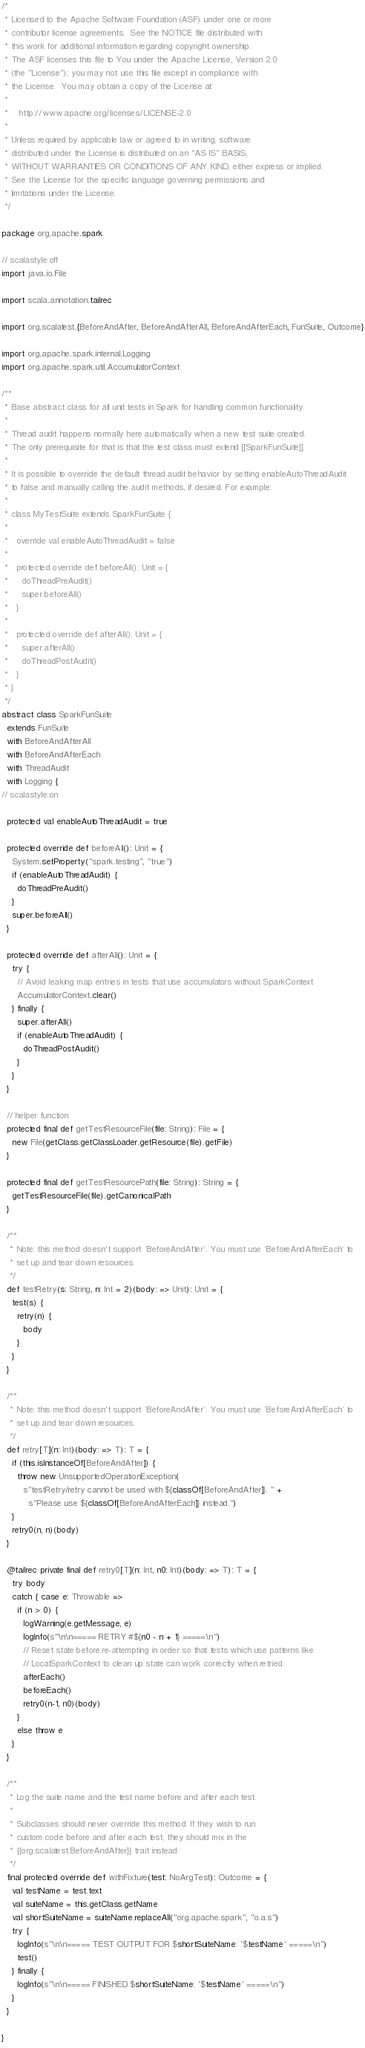Convert code to text. <code><loc_0><loc_0><loc_500><loc_500><_Scala_>/*
 * Licensed to the Apache Software Foundation (ASF) under one or more
 * contributor license agreements.  See the NOTICE file distributed with
 * this work for additional information regarding copyright ownership.
 * The ASF licenses this file to You under the Apache License, Version 2.0
 * (the "License"); you may not use this file except in compliance with
 * the License.  You may obtain a copy of the License at
 *
 *    http://www.apache.org/licenses/LICENSE-2.0
 *
 * Unless required by applicable law or agreed to in writing, software
 * distributed under the License is distributed on an "AS IS" BASIS,
 * WITHOUT WARRANTIES OR CONDITIONS OF ANY KIND, either express or implied.
 * See the License for the specific language governing permissions and
 * limitations under the License.
 */

package org.apache.spark

// scalastyle:off
import java.io.File

import scala.annotation.tailrec

import org.scalatest.{BeforeAndAfter, BeforeAndAfterAll, BeforeAndAfterEach, FunSuite, Outcome}

import org.apache.spark.internal.Logging
import org.apache.spark.util.AccumulatorContext

/**
 * Base abstract class for all unit tests in Spark for handling common functionality.
 *
 * Thread audit happens normally here automatically when a new test suite created.
 * The only prerequisite for that is that the test class must extend [[SparkFunSuite]].
 *
 * It is possible to override the default thread audit behavior by setting enableAutoThreadAudit
 * to false and manually calling the audit methods, if desired. For example:
 *
 * class MyTestSuite extends SparkFunSuite {
 *
 *   override val enableAutoThreadAudit = false
 *
 *   protected override def beforeAll(): Unit = {
 *     doThreadPreAudit()
 *     super.beforeAll()
 *   }
 *
 *   protected override def afterAll(): Unit = {
 *     super.afterAll()
 *     doThreadPostAudit()
 *   }
 * }
 */
abstract class SparkFunSuite
  extends FunSuite
  with BeforeAndAfterAll
  with BeforeAndAfterEach
  with ThreadAudit
  with Logging {
// scalastyle:on

  protected val enableAutoThreadAudit = true

  protected override def beforeAll(): Unit = {
    System.setProperty("spark.testing", "true")
    if (enableAutoThreadAudit) {
      doThreadPreAudit()
    }
    super.beforeAll()
  }

  protected override def afterAll(): Unit = {
    try {
      // Avoid leaking map entries in tests that use accumulators without SparkContext
      AccumulatorContext.clear()
    } finally {
      super.afterAll()
      if (enableAutoThreadAudit) {
        doThreadPostAudit()
      }
    }
  }

  // helper function
  protected final def getTestResourceFile(file: String): File = {
    new File(getClass.getClassLoader.getResource(file).getFile)
  }

  protected final def getTestResourcePath(file: String): String = {
    getTestResourceFile(file).getCanonicalPath
  }

  /**
   * Note: this method doesn't support `BeforeAndAfter`. You must use `BeforeAndAfterEach` to
   * set up and tear down resources.
   */
  def testRetry(s: String, n: Int = 2)(body: => Unit): Unit = {
    test(s) {
      retry(n) {
        body
      }
    }
  }

  /**
   * Note: this method doesn't support `BeforeAndAfter`. You must use `BeforeAndAfterEach` to
   * set up and tear down resources.
   */
  def retry[T](n: Int)(body: => T): T = {
    if (this.isInstanceOf[BeforeAndAfter]) {
      throw new UnsupportedOperationException(
        s"testRetry/retry cannot be used with ${classOf[BeforeAndAfter]}. " +
          s"Please use ${classOf[BeforeAndAfterEach]} instead.")
    }
    retry0(n, n)(body)
  }

  @tailrec private final def retry0[T](n: Int, n0: Int)(body: => T): T = {
    try body
    catch { case e: Throwable =>
      if (n > 0) {
        logWarning(e.getMessage, e)
        logInfo(s"\n\n===== RETRY #${n0 - n + 1} =====\n")
        // Reset state before re-attempting in order so that tests which use patterns like
        // LocalSparkContext to clean up state can work correctly when retried.
        afterEach()
        beforeEach()
        retry0(n-1, n0)(body)
      }
      else throw e
    }
  }

  /**
   * Log the suite name and the test name before and after each test.
   *
   * Subclasses should never override this method. If they wish to run
   * custom code before and after each test, they should mix in the
   * {{org.scalatest.BeforeAndAfter}} trait instead.
   */
  final protected override def withFixture(test: NoArgTest): Outcome = {
    val testName = test.text
    val suiteName = this.getClass.getName
    val shortSuiteName = suiteName.replaceAll("org.apache.spark", "o.a.s")
    try {
      logInfo(s"\n\n===== TEST OUTPUT FOR $shortSuiteName: '$testName' =====\n")
      test()
    } finally {
      logInfo(s"\n\n===== FINISHED $shortSuiteName: '$testName' =====\n")
    }
  }

}
</code> 